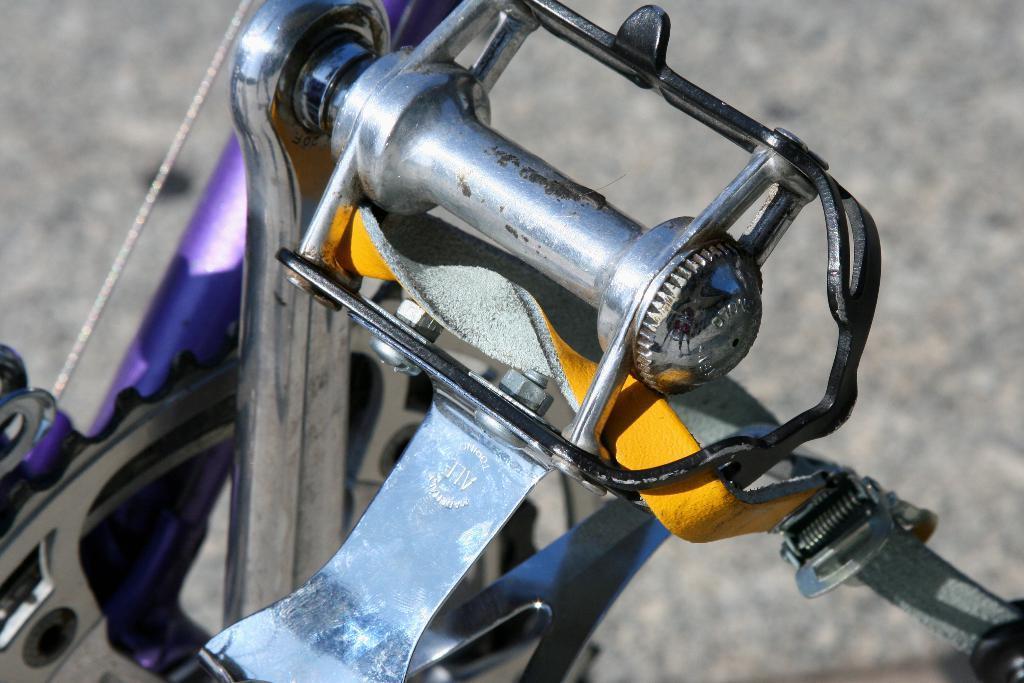How would you summarize this image in a sentence or two? This image consists of some vehicle. It has some screws. 